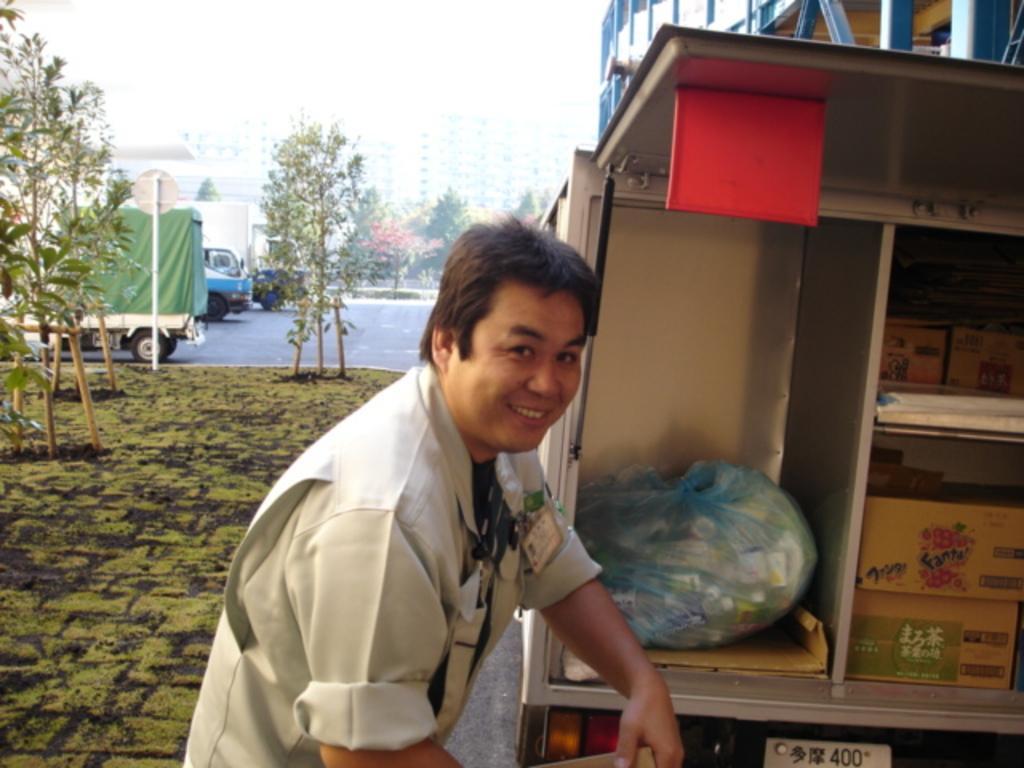In one or two sentences, can you explain what this image depicts? Here a man is standing, here there are boxes and a cover, here there are trees, here vehicles are parked. 